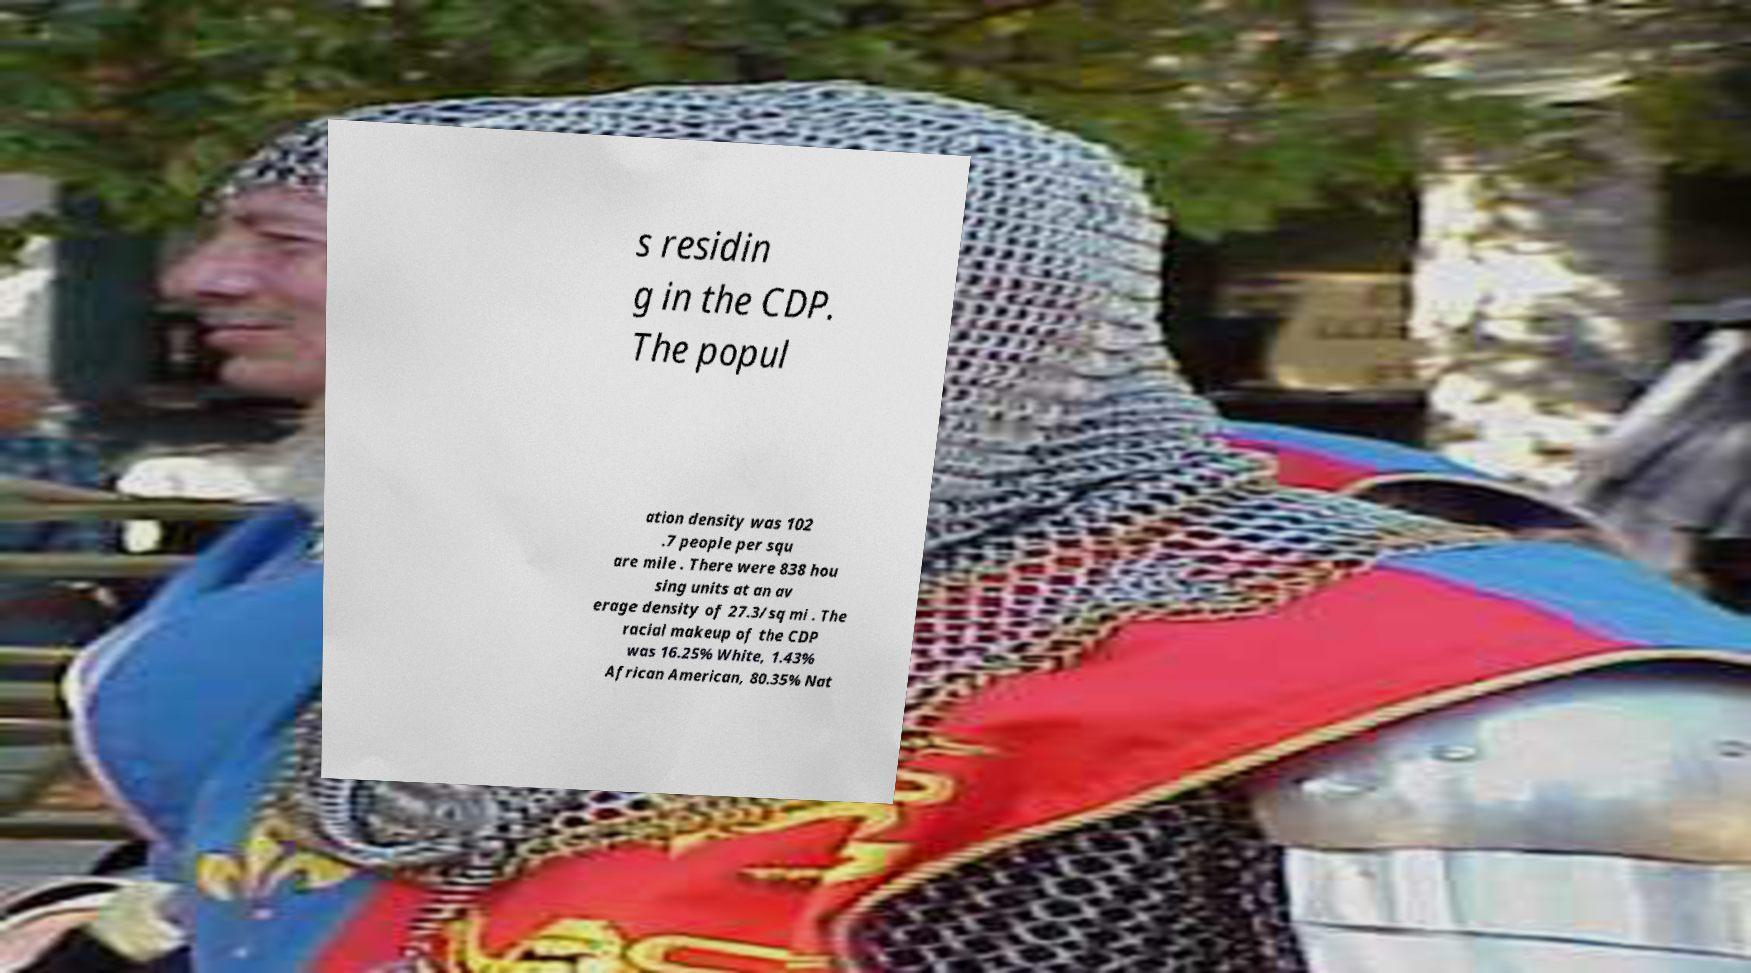For documentation purposes, I need the text within this image transcribed. Could you provide that? s residin g in the CDP. The popul ation density was 102 .7 people per squ are mile . There were 838 hou sing units at an av erage density of 27.3/sq mi . The racial makeup of the CDP was 16.25% White, 1.43% African American, 80.35% Nat 